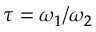Convert formula to latex. <formula><loc_0><loc_0><loc_500><loc_500>\tau = \omega _ { 1 } / \omega _ { 2 }</formula> 